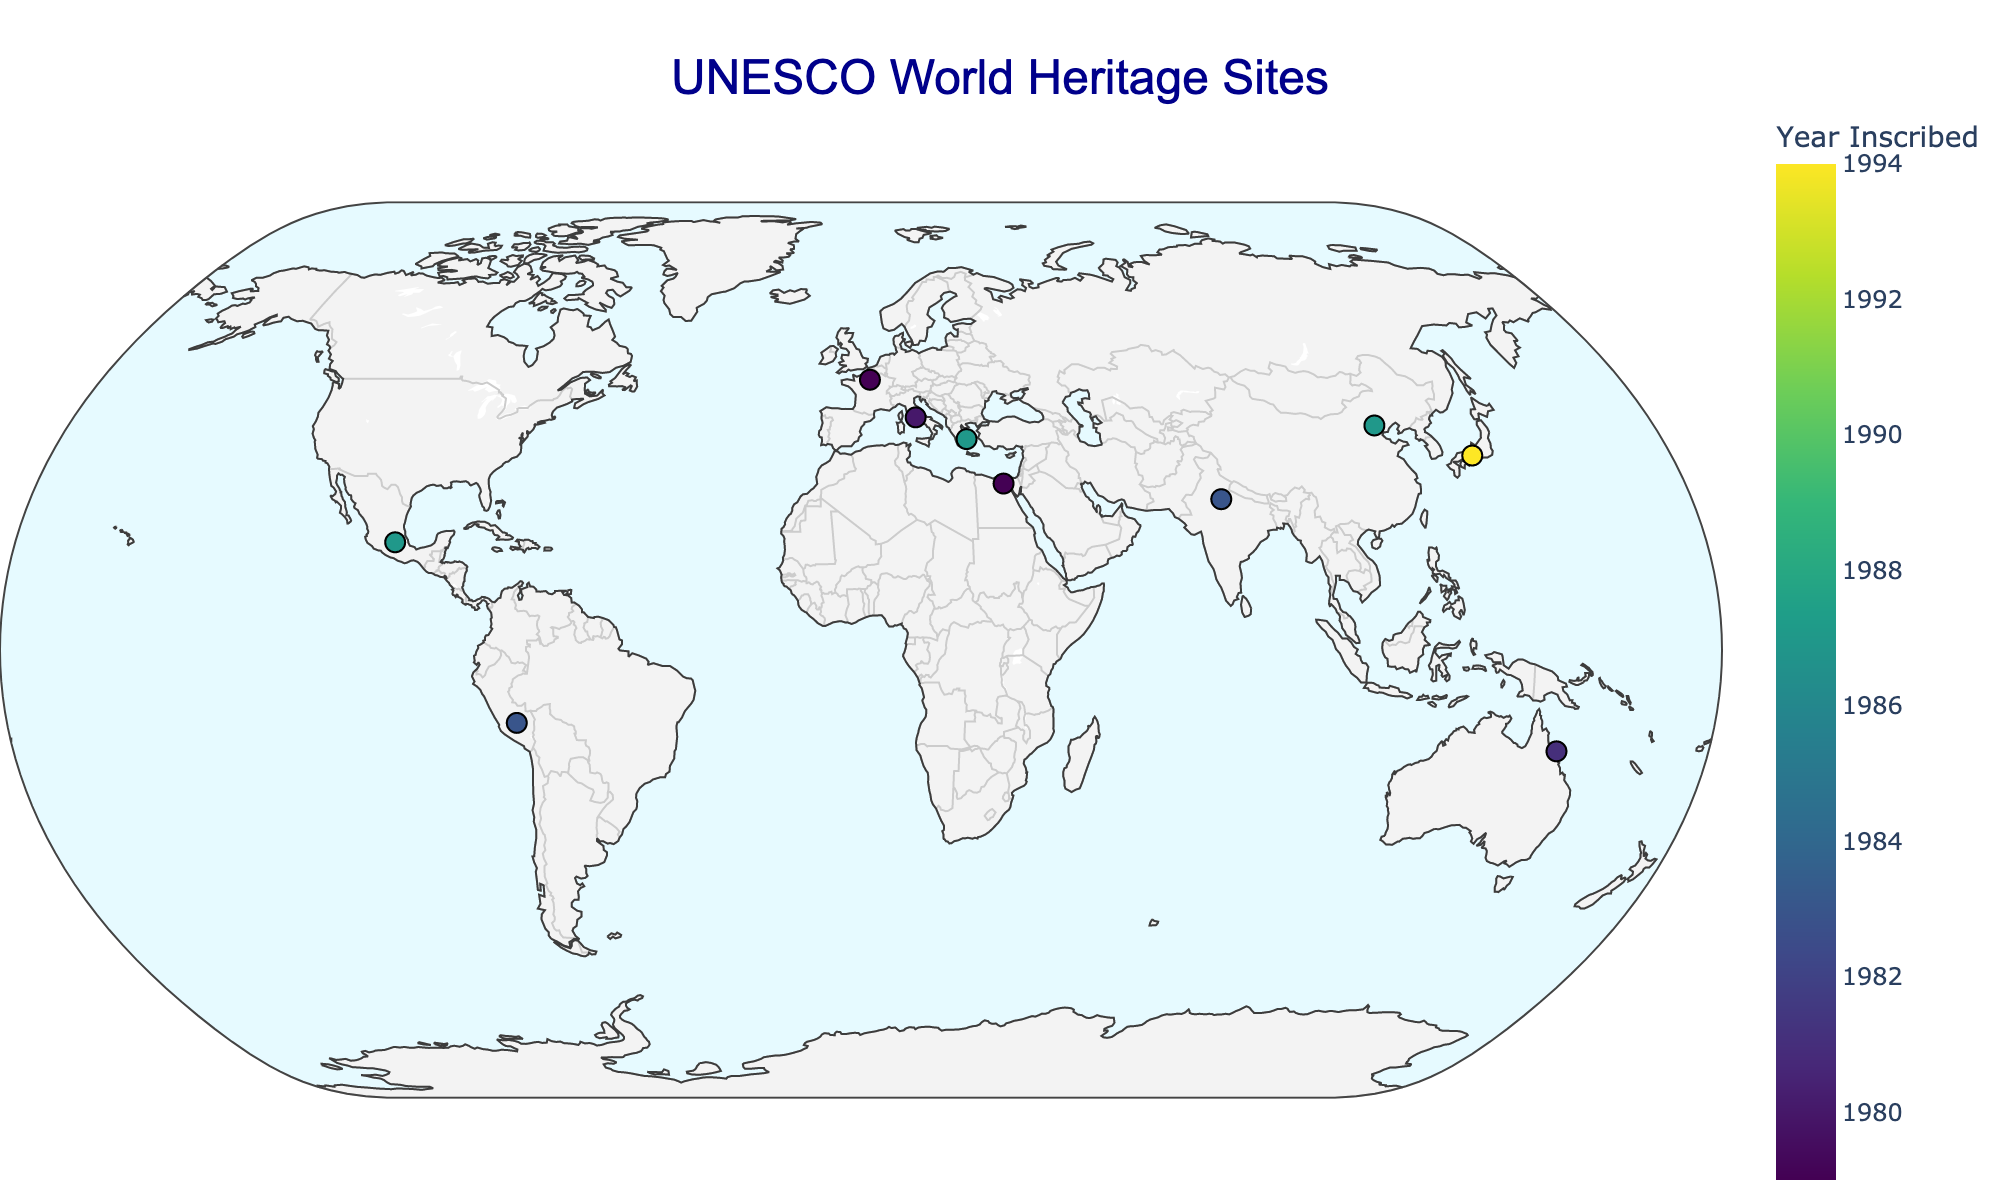what is the title of the figure? The title of the figure is displayed prominently at the top of the plot. It indicates the main focus of the visualization.
Answer: UNESCO World Heritage Sites How many heritage sites are represented in the figure? By counting the number of markers on the plot, each representing a heritage site, we determine the total number of sites shown.
Answer: 10 Which country has the earliest inscribed UNESCO site in the figure? Look at the color bar and find the darkest color on the markers, which correlates to the earliest year of inscription. Then, identify the country associated with this site.
Answer: Egypt Which type of heritage site is the Great Barrier Reef categorized as? By looking at the tooltip information or the cultural significance note when hovering over the Great Barrier Reef marker on the plot, the type of heritage can be identified.
Answer: Natural Which country has the most World Heritage Sites represented in the plot? Scan through the tooltip information for each marker, count the occurrences for each country, and identify which country appears most frequently.
Answer: Italy Are the UNESCO sites more concentrated in any particular continent? Observing the geographic distribution of markers globally, identify if there's a denser concentration of sites in any specific continent or region.
Answer: Europe Which site is inscribed closest to the year 1985? Compare the colors of the markers with the color bar to find the marker closest to the color corresponding to the year 1985 and check the tooltip for the exact year.
Answer: Great Wall of China How does the cultural significance of sites vary across countries? Review the cultural significance described in the tooltips for each marker and summarize the thematic elements and historical importance across different countries.
Answer: Varies significantly from ancient civilizations (Rome, Great Wall) to architectural marvels (Taj Mahal) and unique ecosystems (Great Barrier Reef) What is the latitude and longitude of the Taj Mahal? Hovering over the marker representing the Taj Mahal on the plot will reveal its geographic coordinates in the tooltip.
Answer: 27.1751, 78.0421 Compare the cultural significance between the Historic Centre of Rome and the Acropolis of Athens. Examine the tooltips for both markers. Sum up and compare the key aspects of their cultural significance based on the provided descriptions.
Answer: Rome: Ancient Roman civilization and architecture; Athens: Ancient Greek democracy and architecture 